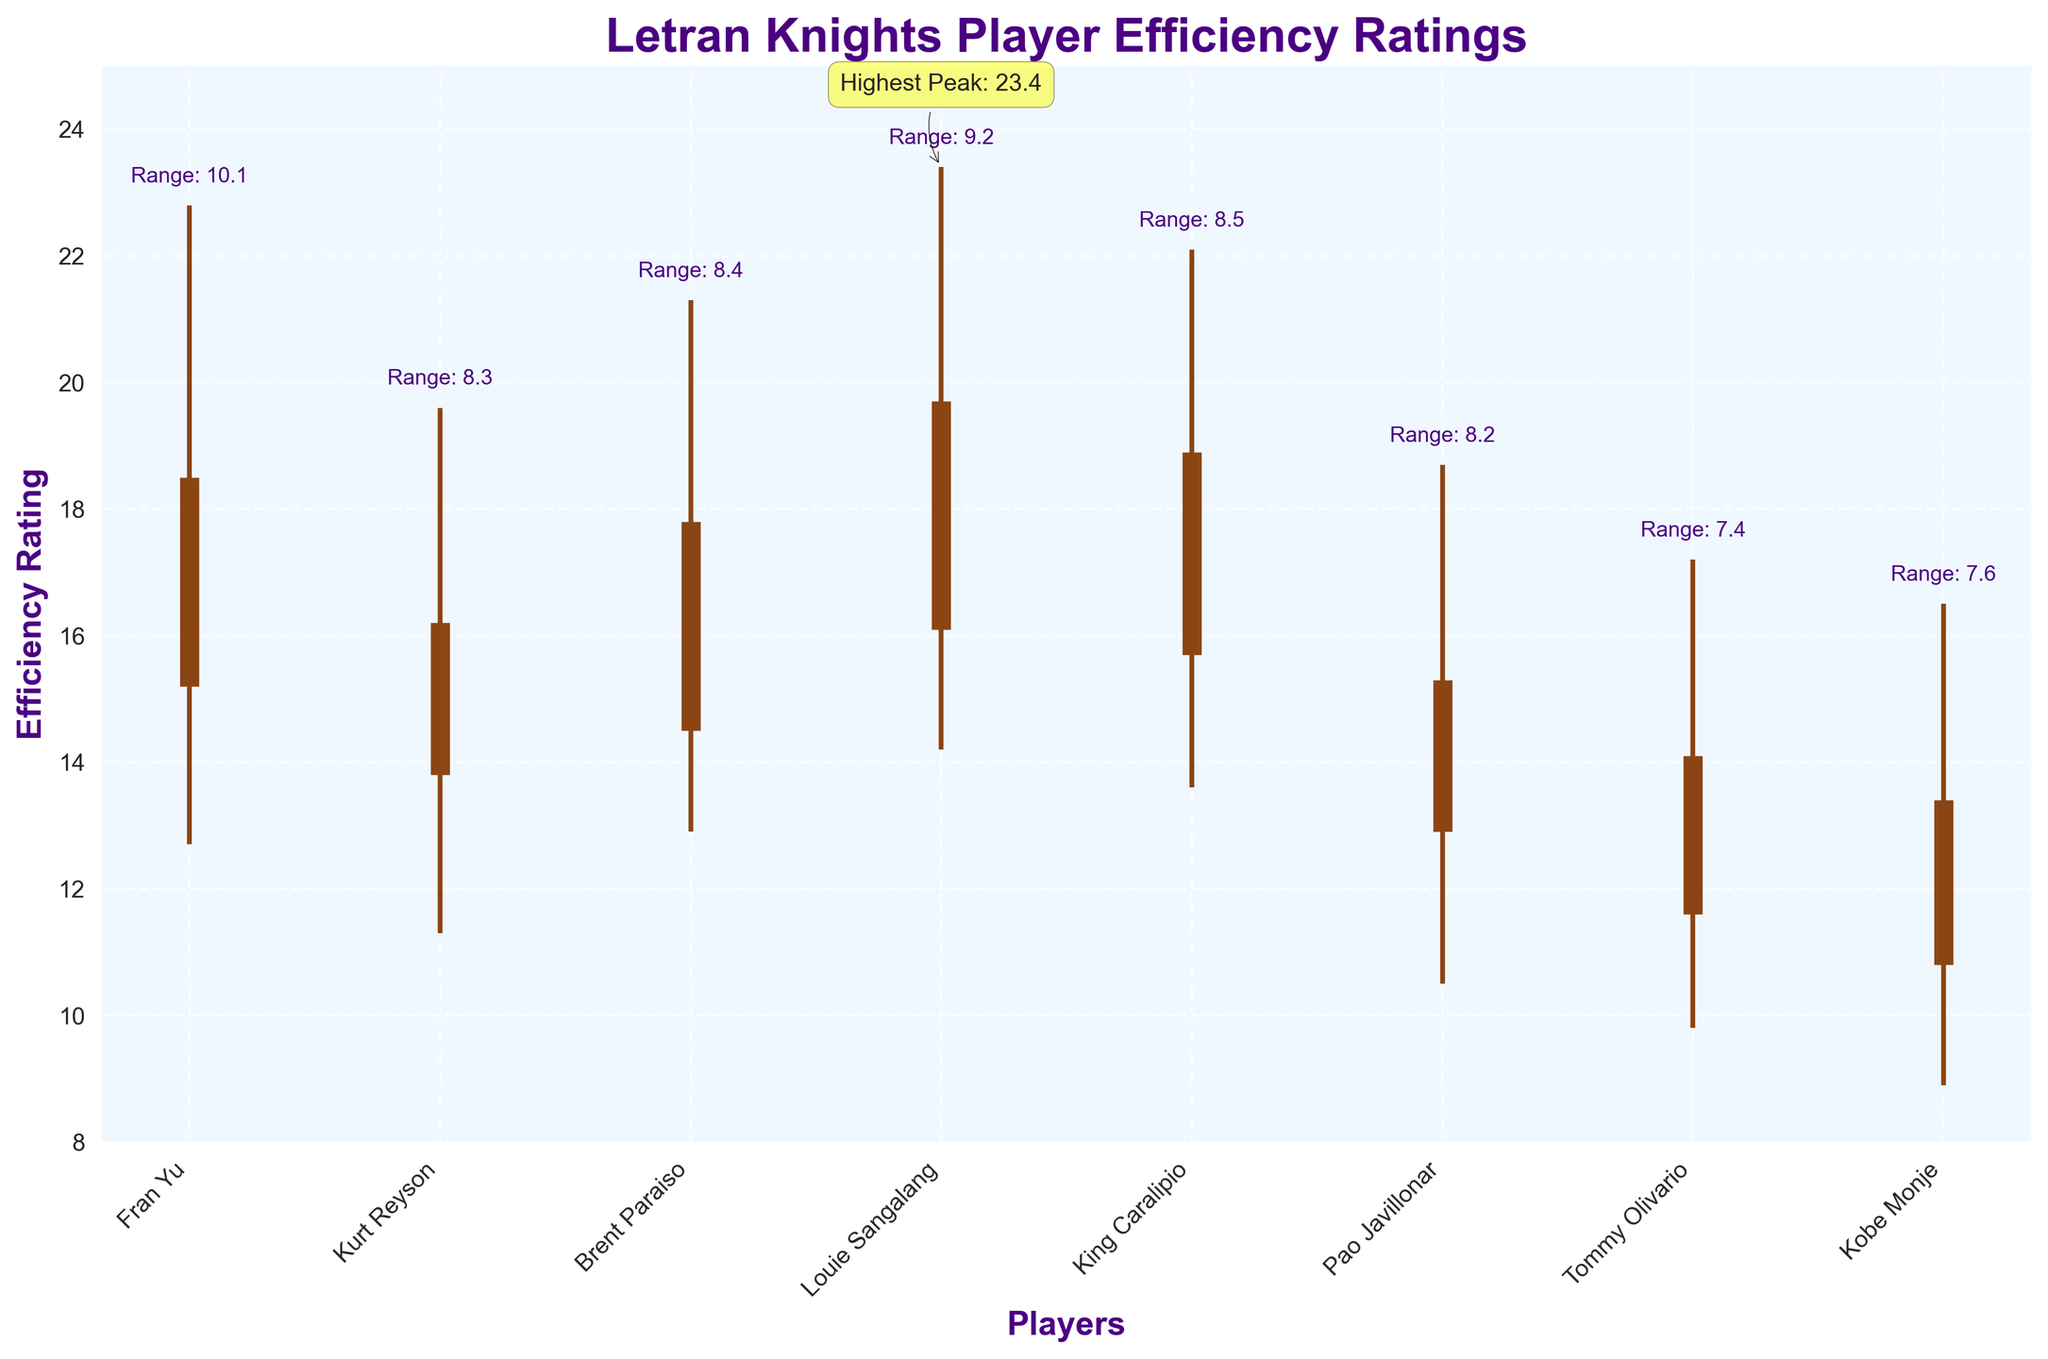What's the title of the figure? Look at the top of the figure where the title is usually located. The title is "Letran Knights Player Efficiency Ratings".
Answer: "Letran Knights Player Efficiency Ratings" What is Louie Sangalang's peak efficiency rating? Locate Louie Sangalang in the plot and look for the highest point in his vertical line. His peak efficiency rating is shown at 23.4.
Answer: 23.4 Which player has the lowest opening efficiency rating? Compare the opening efficiency ratings (thicker vertical segments starting from the bottom) for all players and find the lowest one. Tommy Olivario has the lowest opening rating of 11.6.
Answer: Tommy Olivario What is the efficiency range for King Caralipio? Find the peak and lowest efficiency ratings for King Caralipio, then calculate the range by subtracting the lowest from the peak: 22.1 - 13.6 = 8.5.
Answer: 8.5 How many players have a final efficiency rating above 18? Count the number of players whose final efficiency rating (the top of the thicker vertical segments) is above 18. Fran Yu, Louie Sangalang, and King Caralipio have final ratings above 18.
Answer: 3 Which player has the highest peak efficiency rating and what is it? Determine the highest position of the vertical peak lines among all players. Louie Sangalang has the highest peak with a rating of 23.4.
Answer: Louie Sangalang, 23.4 What is the difference between Fran Yu's and Kurt Reyson's lowest efficiency ratings? Identify Fran Yu's and Kurt Reyson's lowest efficiency ratings and subtract one from the other: 12.7 - 11.3 = 1.4.
Answer: 1.4 Which player shows the highest improvement from their opening to final rating? Calculate the difference between the opening and final ratings for each player. Fran Yu’s improvement: 18.5 - 15.2 = 3.3; Kurt Reyson’s improvement: 16.2 - 13.8 = 2.4; Brent Paraiso’s improvement: 17.8 - 14.5 = 3.3; Louie Sangalang’s improvement: 19.7 - 16.1 = 3.6; King Caralipio’s improvement: 18.9 - 15.7 = 3.2; Pao Javillonar’s improvement: 15.3 - 12.9 = 2.4; Tommy Olivario’s improvement: 14.1 - 11.6 = 2.5; Kobe Monje’s improvement: 13.4 - 10.8 = 2.6. Louie Sangalang has the highest improvement of 3.6.
Answer: Louie Sangalang Which player's range between peak and lowest rating is closest to 7? Calculate the range for each player and find which one is closest to 7. Fran Yu: 22.8 - 12.7 = 10.1; Kurt Reyson: 19.6 - 11.3 = 8.3; Brent Paraiso: 21.3 - 12.9 = 8.4; Louie Sangalang: 23.4 - 14.2 = 9.2; King Caralipio: 22.1 - 13.6 = 8.5; Pao Javillonar: 18.7 - 10.5 = 8.2; Tommy Olivario: 17.2 - 9.8 = 7.4; Kobe Monje: 16.5 - 8.9 = 7.6. Tommy Olivario’s range is closest to 7.
Answer: Tommy Olivario 